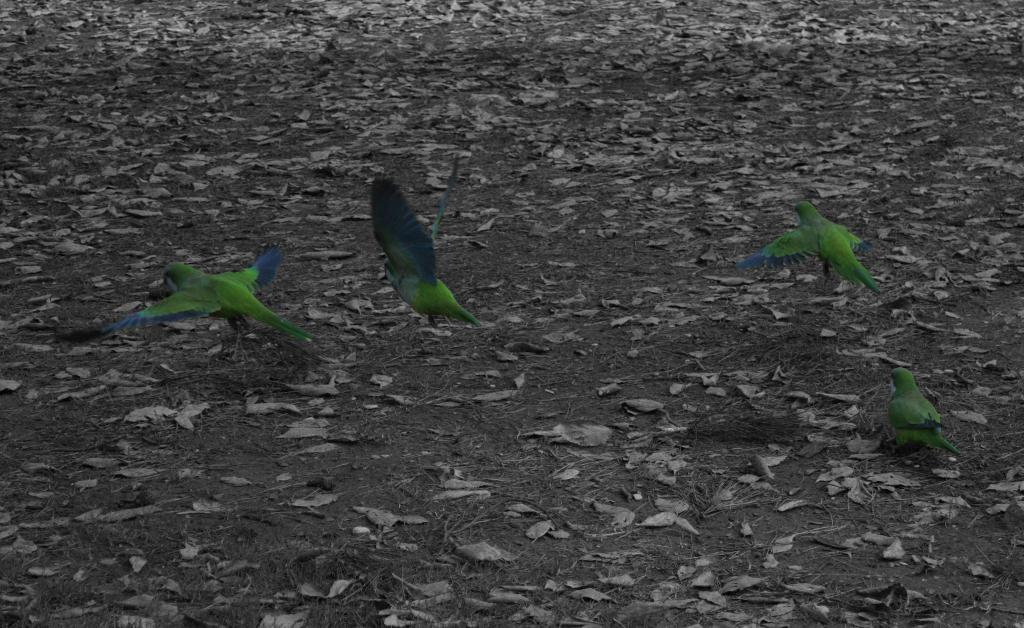How many parrots are in the image? There are four green parrots in the image. What are the parrots doing in the image? Three of the parrots are flying in the air, and one parrot is standing on the ground. What can be found on the ground in the image? There are dry leaves on the ground. What type of team is performing on the stage in the image? There is no team or stage present in the image; it features four green parrots. How many seats are available for the audience in the image? There are no seats or audience present in the image; it features four green parrots. 